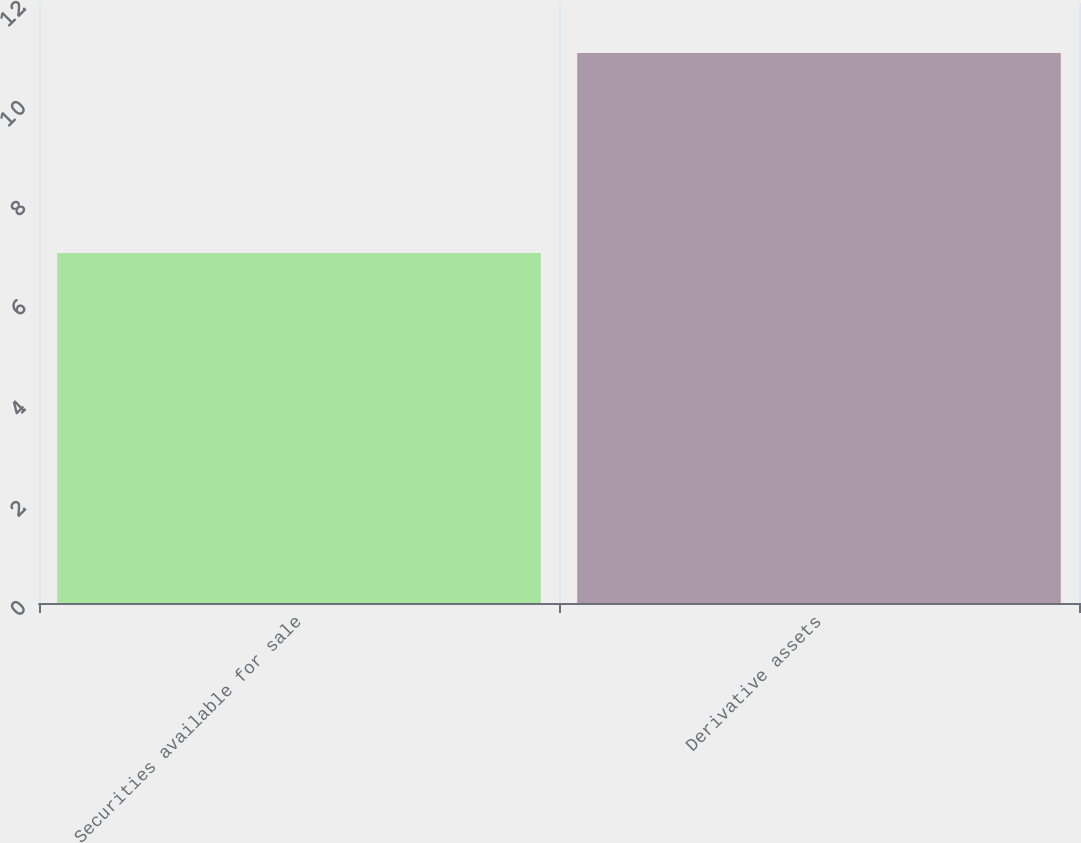Convert chart to OTSL. <chart><loc_0><loc_0><loc_500><loc_500><bar_chart><fcel>Securities available for sale<fcel>Derivative assets<nl><fcel>7<fcel>11<nl></chart> 